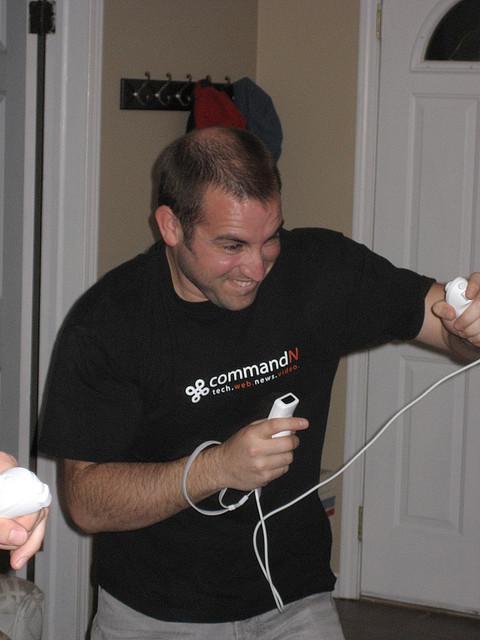What is wrapped around his wrist?
Select the accurate answer and provide justification: `Answer: choice
Rationale: srationale.`
Options: Yarn, string, cord, ribbon. Answer: cord.
Rationale: The man in the photo is carrying wii controllers in his hand.  connected to these are cords which wrap around his wrists. 